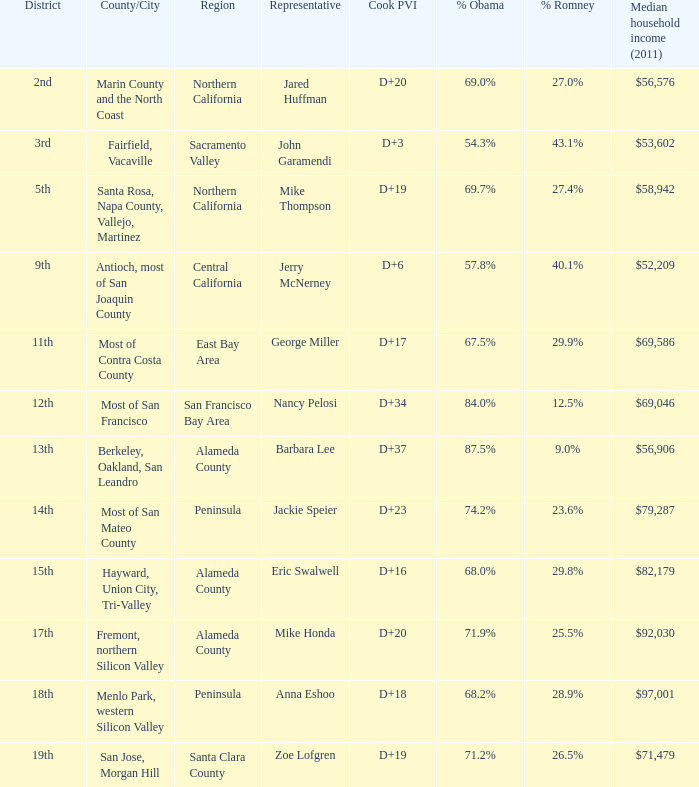What is the 2012 election results for locations whose representative is Barbara Lee? 87.5%–9.0% Obama. 